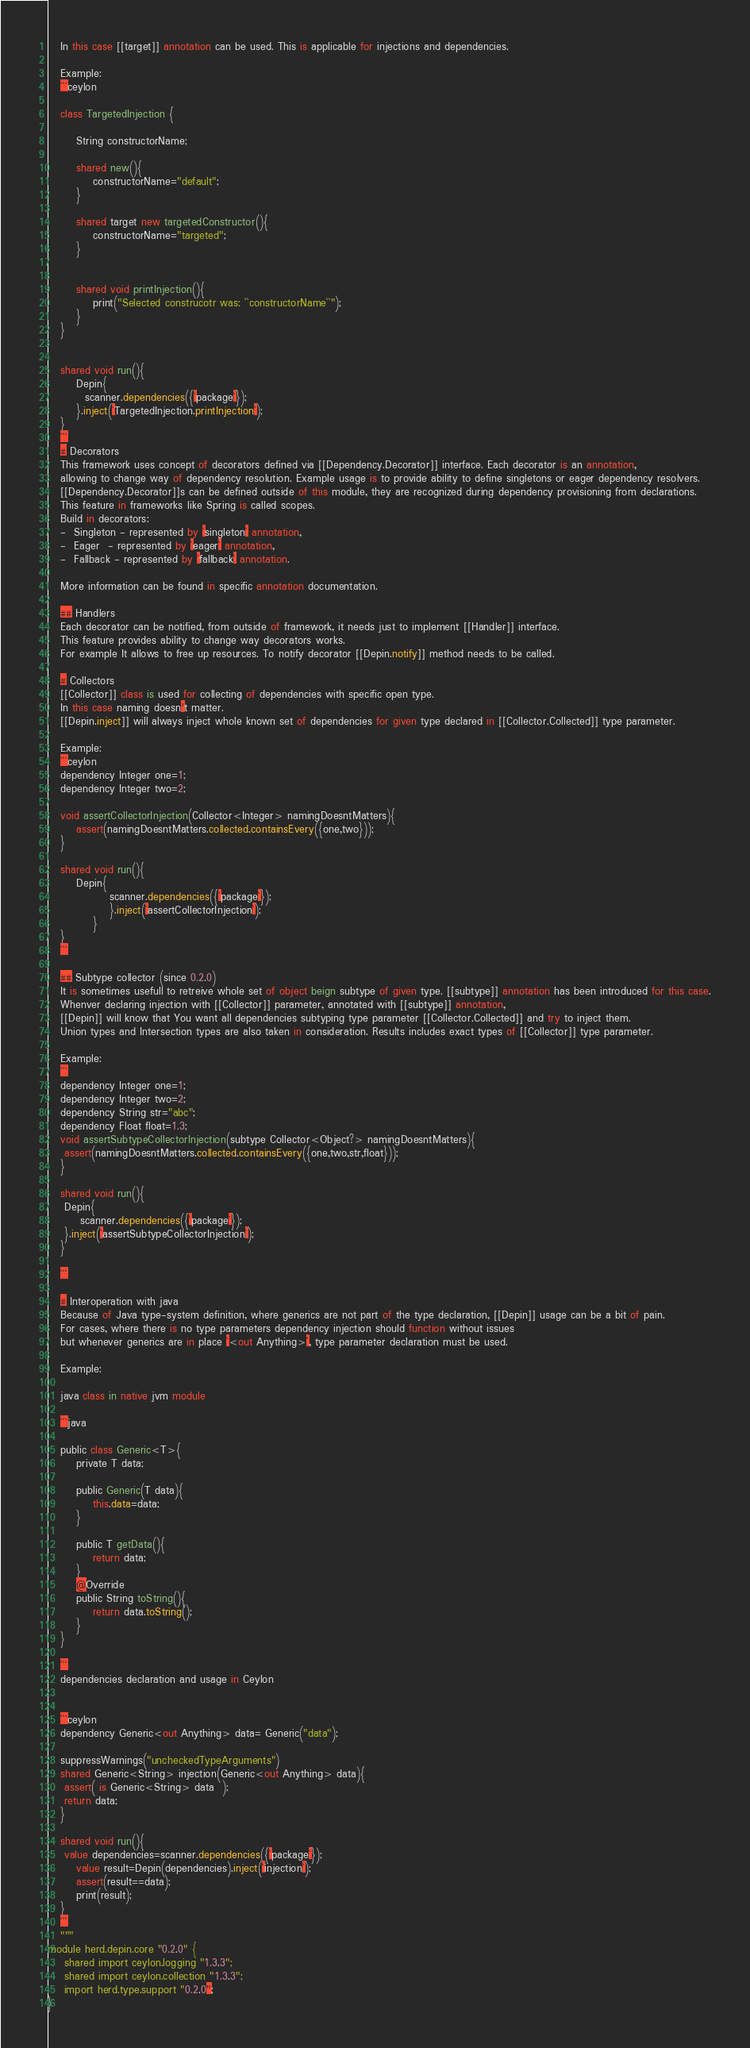<code> <loc_0><loc_0><loc_500><loc_500><_Ceylon_>   In this case [[target]] annotation can be used. This is applicable for injections and dependencies. 
   
   Example:
   ```ceylon
   
   class TargetedInjection {
   
	   String constructorName;
	   
	   shared new(){
	   	   constructorName="default";
	   }
	   
	   shared target new targetedConstructor(){
	   	   constructorName="targeted";
	   }
	   
	   
	   shared void printInjection(){
	   	   print("Selected construcotr was: ``constructorName``");
	   }
   }
   
   
   shared void run(){
	   Depin{
	  	 scanner.dependencies({`package`});
	   }.inject(`TargetedInjection.printInjection`);
   } 
   ```
   # Decorators 
   This framework uses concept of decorators defined via [[Dependency.Decorator]] interface. Each decorator is an annotation, 
   allowing to change way of dependency resolution. Example usage is to provide ability to define singletons or eager dependency resolvers.
   [[Dependency.Decorator]]s can be defined outside of this module, they are recognized during dependency provisioning from declarations.
   This feature in frameworks like Spring is called scopes. 
   Build in decorators: 
   -  Singleton - represented by `singleton` annotation,
   -  Eager  - represented by `eager` annotation,
   -  Fallback - represented by `fallback` annotation.
   
   More information can be found in specific annotation documentation.
   
   ## Handlers 
   Each decorator can be notified, from outside of framework, it needs just to implement [[Handler]] interface.
   This feature provides ability to change way decorators works.
   For example It allows to free up resources. To notify decorator [[Depin.notify]] method needs to be called. 
   
   # Collectors 
   [[Collector]] class is used for collecting of dependencies with specific open type.
   In this case naming doesn't matter. 
   [[Depin.inject]] will always inject whole known set of dependencies for given type declared in [[Collector.Collected]] type parameter.
   
   Example:
   ```ceylon
   dependency Integer one=1;
   dependency Integer two=2;
   
   void assertCollectorInjection(Collector<Integer> namingDoesntMatters){
   	   assert(namingDoesntMatters.collected.containsEvery({one,two}));
   }
   
   shared void run(){
	   Depin{
			   scanner.dependencies({`package`});
			   }.inject(`assertCollectorInjection`);
		   }
   } 
   ```
   
   ## Subtype collector (since 0.2.0)
   It is sometimes usefull to retreive whole set of object beign subtype of given type. [[subtype]] annotation has been introduced for this case.
   Whenver declaring injection with [[Collector]] parameter, annotated with [[subtype]] annotation, 
   [[Depin]] will know that You want all dependencies subtyping type parameter [[Collector.Collected]] and try to inject them.
   Union types and Intersection types are also taken in consideration. Results includes exact types of [[Collector]] type parameter. 
   
   Example:
   ```
   dependency Integer one=1;
   dependency Integer two=2;
   dependency String str="abc";
   dependency Float float=1.3;
   void assertSubtypeCollectorInjection(subtype Collector<Object?> namingDoesntMatters){
   	assert(namingDoesntMatters.collected.containsEvery({one,two,str,float}));
   }
   
   shared void run(){
   	Depin{
   		scanner.dependencies({`package`});
   	}.inject(`assertSubtypeCollectorInjection`);
   }

   ```
   
   # Interoperation with java
   Because of Java type-system definition, where generics are not part of the type declaration, [[Depin]] usage can be a bit of pain. 
   For cases, where there is no type parameters dependency injection should function without issues 
   but whenever generics are in place `<out Anything>`, type parameter declaration must be used.  
   
   Example:
   
   java class in native jvm module
   
   ```java
   
   public class Generic<T>{
	   private T data;
	   
	   public Generic(T data){
	   	   this.data=data;
	   }
	   
	   public T getData(){
	       return data;
	   }
	   @Override
	   public String toString(){
	   	   return data.toString();
	   }
   }
   
   ```
   dependencies declaration and usage in Ceylon
   
   
   ```ceylon
   dependency Generic<out Anything> data= Generic("data");
   
   suppressWarnings("uncheckedTypeArguments")
   shared Generic<String> injection(Generic<out Anything> data){
   	assert( is Generic<String> data  );
  	return data;
   }
   
   shared void run(){
   	value dependencies=scanner.dependencies({`package`});
	   value result=Depin(dependencies).inject(`injection`);
	   assert(result==data);
	   print(result);
   }
   ```   
   """
module herd.depin.core "0.2.0" {
	shared import ceylon.logging "1.3.3";
	shared import ceylon.collection "1.3.3";
	import herd.type.support "0.2.0";
}
</code> 